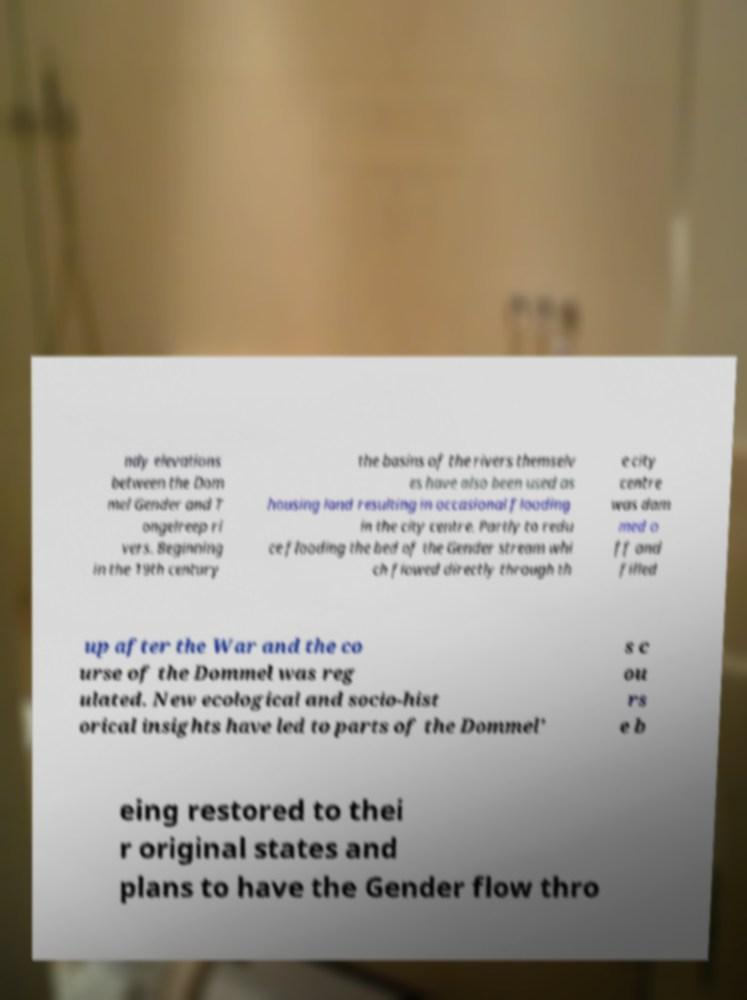Could you extract and type out the text from this image? ndy elevations between the Dom mel Gender and T ongelreep ri vers. Beginning in the 19th century the basins of the rivers themselv es have also been used as housing land resulting in occasional flooding in the city centre. Partly to redu ce flooding the bed of the Gender stream whi ch flowed directly through th e city centre was dam med o ff and filled up after the War and the co urse of the Dommel was reg ulated. New ecological and socio-hist orical insights have led to parts of the Dommel' s c ou rs e b eing restored to thei r original states and plans to have the Gender flow thro 